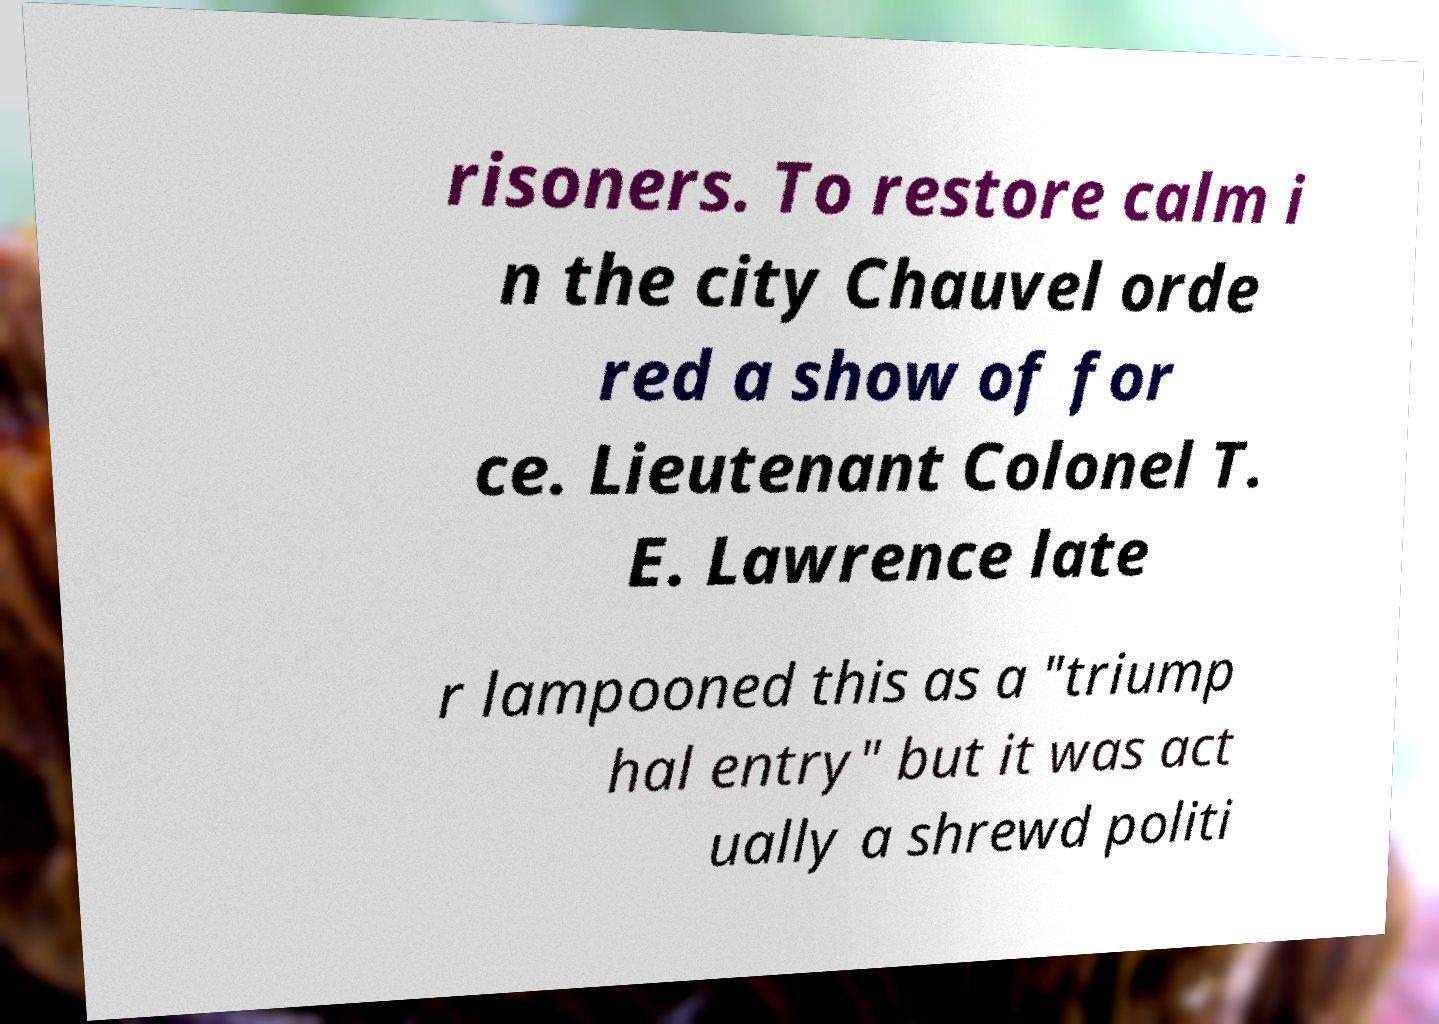Please identify and transcribe the text found in this image. risoners. To restore calm i n the city Chauvel orde red a show of for ce. Lieutenant Colonel T. E. Lawrence late r lampooned this as a "triump hal entry" but it was act ually a shrewd politi 